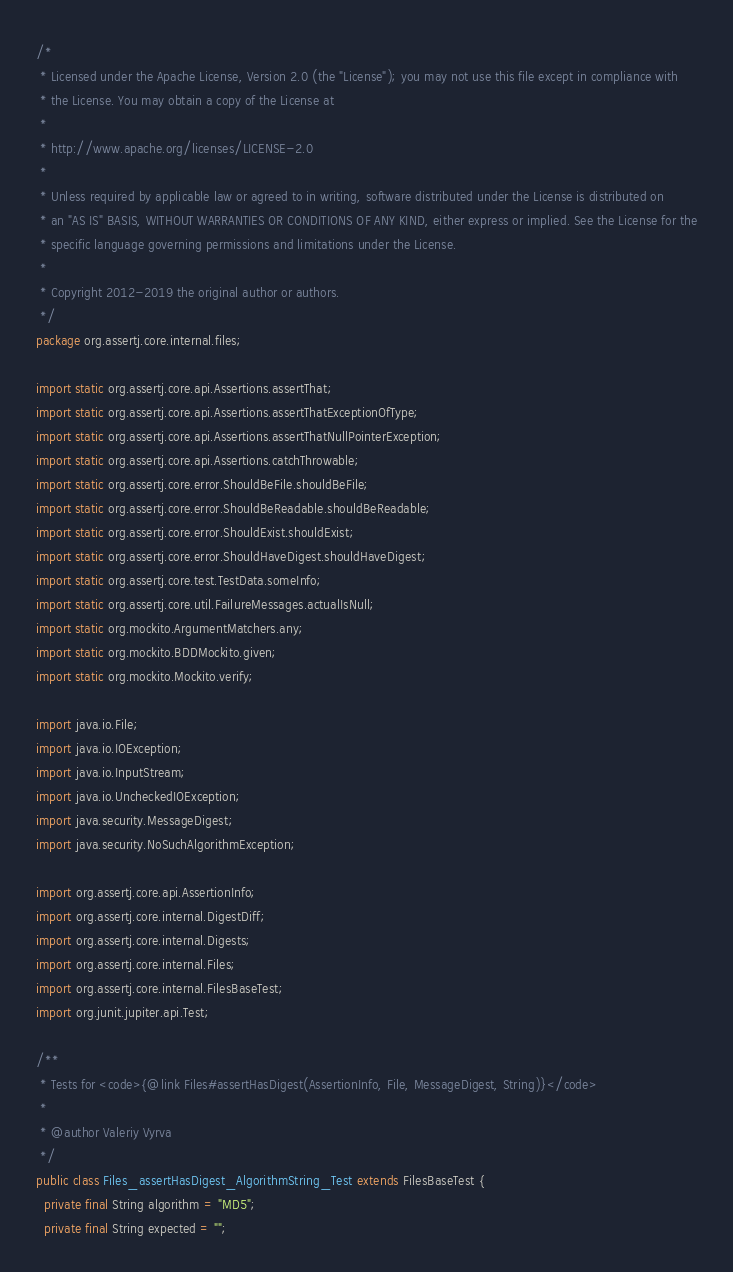Convert code to text. <code><loc_0><loc_0><loc_500><loc_500><_Java_>/*
 * Licensed under the Apache License, Version 2.0 (the "License"); you may not use this file except in compliance with
 * the License. You may obtain a copy of the License at
 *
 * http://www.apache.org/licenses/LICENSE-2.0
 *
 * Unless required by applicable law or agreed to in writing, software distributed under the License is distributed on
 * an "AS IS" BASIS, WITHOUT WARRANTIES OR CONDITIONS OF ANY KIND, either express or implied. See the License for the
 * specific language governing permissions and limitations under the License.
 *
 * Copyright 2012-2019 the original author or authors.
 */
package org.assertj.core.internal.files;

import static org.assertj.core.api.Assertions.assertThat;
import static org.assertj.core.api.Assertions.assertThatExceptionOfType;
import static org.assertj.core.api.Assertions.assertThatNullPointerException;
import static org.assertj.core.api.Assertions.catchThrowable;
import static org.assertj.core.error.ShouldBeFile.shouldBeFile;
import static org.assertj.core.error.ShouldBeReadable.shouldBeReadable;
import static org.assertj.core.error.ShouldExist.shouldExist;
import static org.assertj.core.error.ShouldHaveDigest.shouldHaveDigest;
import static org.assertj.core.test.TestData.someInfo;
import static org.assertj.core.util.FailureMessages.actualIsNull;
import static org.mockito.ArgumentMatchers.any;
import static org.mockito.BDDMockito.given;
import static org.mockito.Mockito.verify;

import java.io.File;
import java.io.IOException;
import java.io.InputStream;
import java.io.UncheckedIOException;
import java.security.MessageDigest;
import java.security.NoSuchAlgorithmException;

import org.assertj.core.api.AssertionInfo;
import org.assertj.core.internal.DigestDiff;
import org.assertj.core.internal.Digests;
import org.assertj.core.internal.Files;
import org.assertj.core.internal.FilesBaseTest;
import org.junit.jupiter.api.Test;

/**
 * Tests for <code>{@link Files#assertHasDigest(AssertionInfo, File, MessageDigest, String)}</code>
 *
 * @author Valeriy Vyrva
 */
public class Files_assertHasDigest_AlgorithmString_Test extends FilesBaseTest {
  private final String algorithm = "MD5";
  private final String expected = "";</code> 